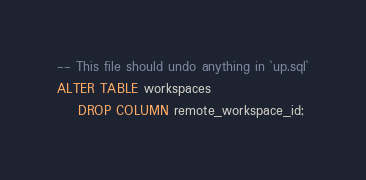<code> <loc_0><loc_0><loc_500><loc_500><_SQL_>-- This file should undo anything in `up.sql`
ALTER TABLE workspaces
    DROP COLUMN remote_workspace_id;
</code> 